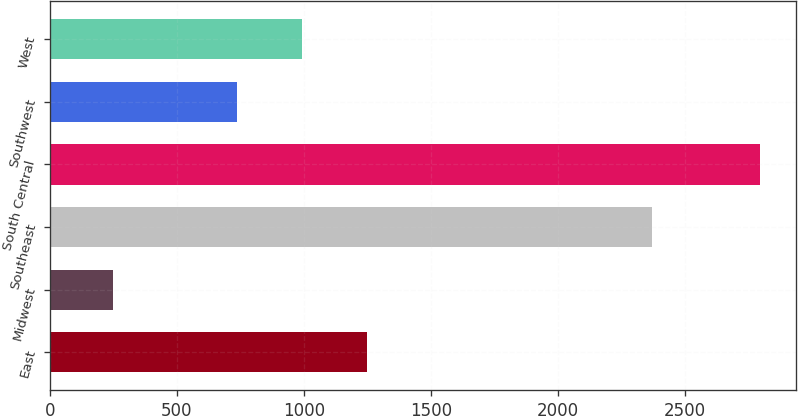Convert chart to OTSL. <chart><loc_0><loc_0><loc_500><loc_500><bar_chart><fcel>East<fcel>Midwest<fcel>Southeast<fcel>South Central<fcel>Southwest<fcel>West<nl><fcel>1247.2<fcel>248<fcel>2369<fcel>2794<fcel>738<fcel>992.6<nl></chart> 